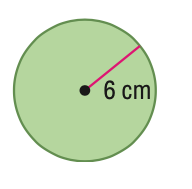Answer the mathemtical geometry problem and directly provide the correct option letter.
Question: Find the area of the circle. Round to the nearest tenth.
Choices: A: 18.8 B: 37.7 C: 113.1 D: 452.4 C 